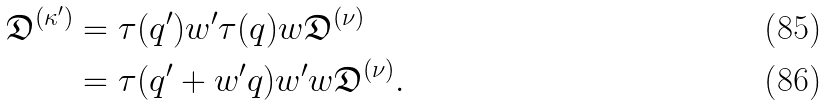Convert formula to latex. <formula><loc_0><loc_0><loc_500><loc_500>\mathfrak { D } ^ { ( \kappa ^ { \prime } ) } & = \tau ( q ^ { \prime } ) w ^ { \prime } \tau ( q ) w \mathfrak { D } ^ { ( \nu ) } \\ & = \tau ( q ^ { \prime } + w ^ { \prime } q ) w ^ { \prime } w \mathfrak { D } ^ { ( \nu ) } .</formula> 